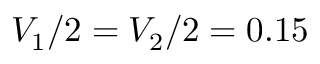Convert formula to latex. <formula><loc_0><loc_0><loc_500><loc_500>V _ { 1 } / 2 = V _ { 2 } / 2 = 0 . 1 5</formula> 